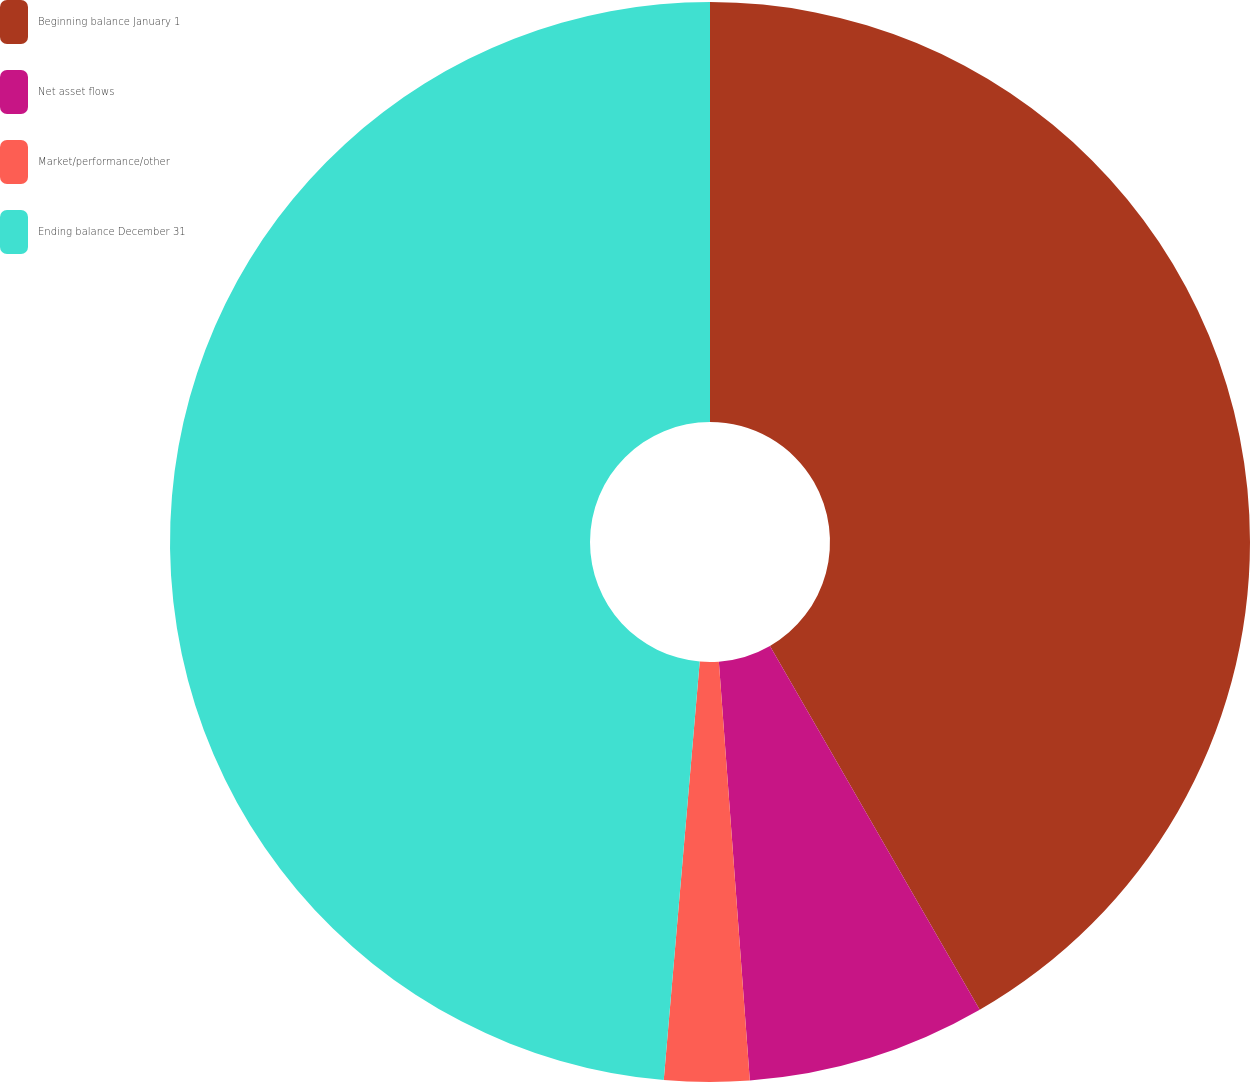<chart> <loc_0><loc_0><loc_500><loc_500><pie_chart><fcel>Beginning balance January 1<fcel>Net asset flows<fcel>Market/performance/other<fcel>Ending balance December 31<nl><fcel>41.68%<fcel>7.15%<fcel>2.54%<fcel>48.64%<nl></chart> 